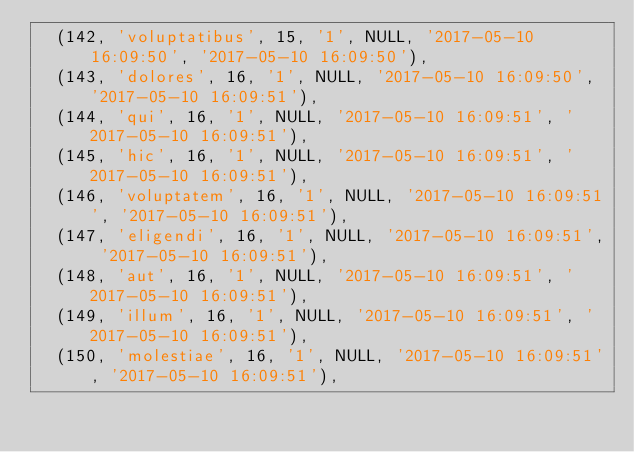<code> <loc_0><loc_0><loc_500><loc_500><_SQL_>	(142, 'voluptatibus', 15, '1', NULL, '2017-05-10 16:09:50', '2017-05-10 16:09:50'),
	(143, 'dolores', 16, '1', NULL, '2017-05-10 16:09:50', '2017-05-10 16:09:51'),
	(144, 'qui', 16, '1', NULL, '2017-05-10 16:09:51', '2017-05-10 16:09:51'),
	(145, 'hic', 16, '1', NULL, '2017-05-10 16:09:51', '2017-05-10 16:09:51'),
	(146, 'voluptatem', 16, '1', NULL, '2017-05-10 16:09:51', '2017-05-10 16:09:51'),
	(147, 'eligendi', 16, '1', NULL, '2017-05-10 16:09:51', '2017-05-10 16:09:51'),
	(148, 'aut', 16, '1', NULL, '2017-05-10 16:09:51', '2017-05-10 16:09:51'),
	(149, 'illum', 16, '1', NULL, '2017-05-10 16:09:51', '2017-05-10 16:09:51'),
	(150, 'molestiae', 16, '1', NULL, '2017-05-10 16:09:51', '2017-05-10 16:09:51'),</code> 